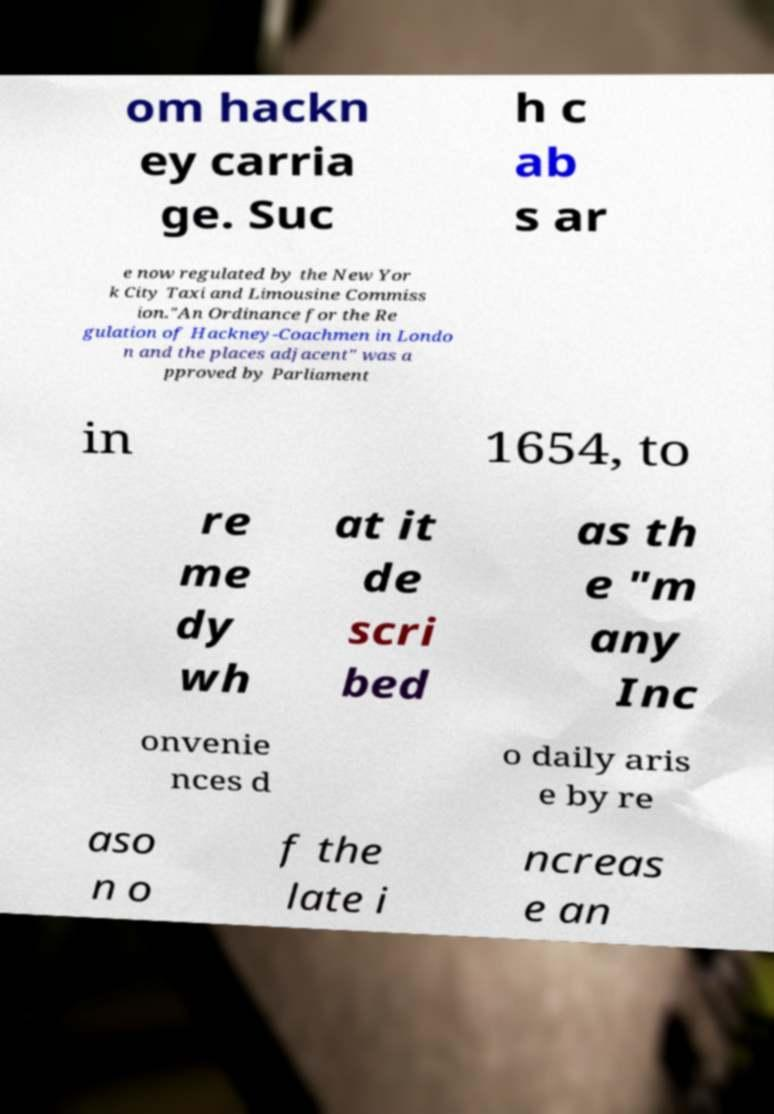What messages or text are displayed in this image? I need them in a readable, typed format. om hackn ey carria ge. Suc h c ab s ar e now regulated by the New Yor k City Taxi and Limousine Commiss ion."An Ordinance for the Re gulation of Hackney-Coachmen in Londo n and the places adjacent" was a pproved by Parliament in 1654, to re me dy wh at it de scri bed as th e "m any Inc onvenie nces d o daily aris e by re aso n o f the late i ncreas e an 